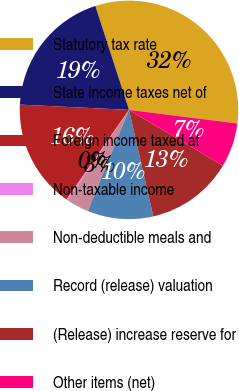Convert chart. <chart><loc_0><loc_0><loc_500><loc_500><pie_chart><fcel>Statutory tax rate<fcel>State income taxes net of<fcel>Foreign income taxed at<fcel>Non-taxable income<fcel>Non-deductible meals and<fcel>Record (release) valuation<fcel>(Release) increase reserve for<fcel>Other items (net)<nl><fcel>31.97%<fcel>19.25%<fcel>16.08%<fcel>0.18%<fcel>3.36%<fcel>9.72%<fcel>12.9%<fcel>6.54%<nl></chart> 